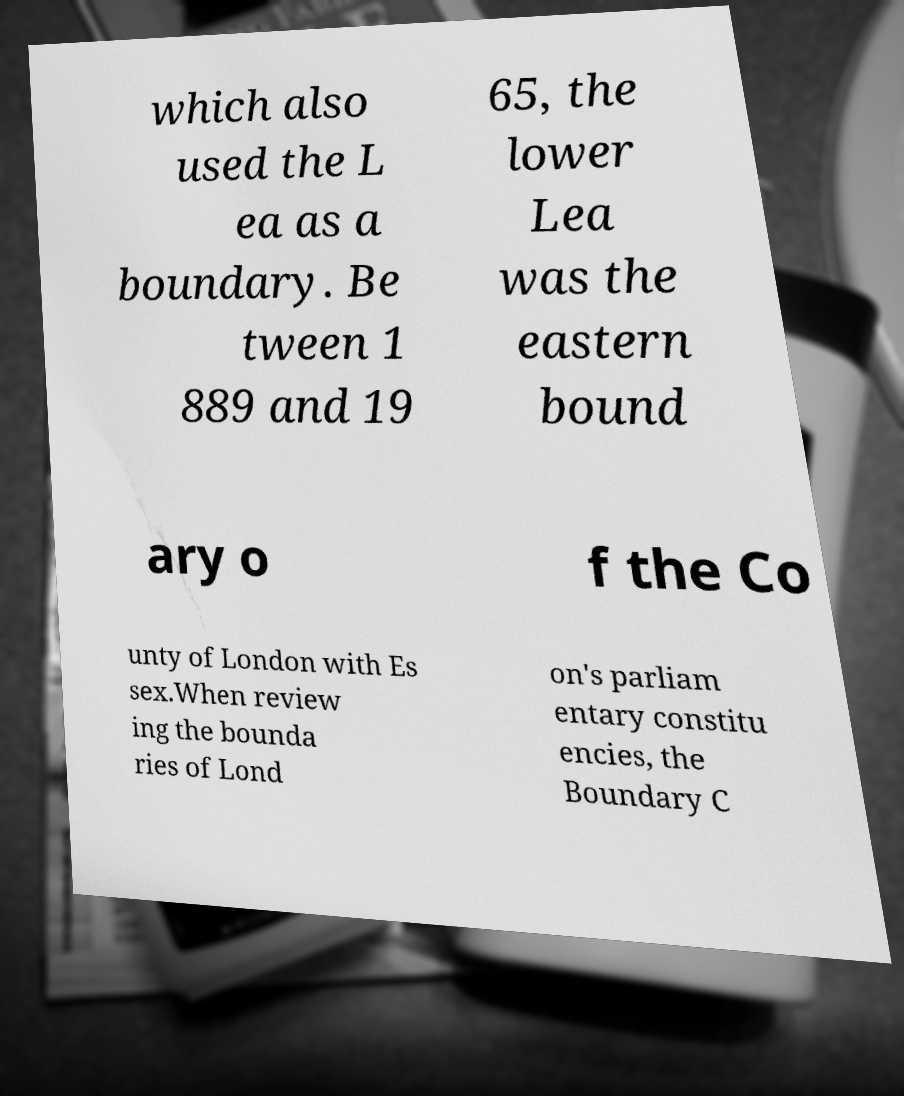For documentation purposes, I need the text within this image transcribed. Could you provide that? which also used the L ea as a boundary. Be tween 1 889 and 19 65, the lower Lea was the eastern bound ary o f the Co unty of London with Es sex.When review ing the bounda ries of Lond on's parliam entary constitu encies, the Boundary C 